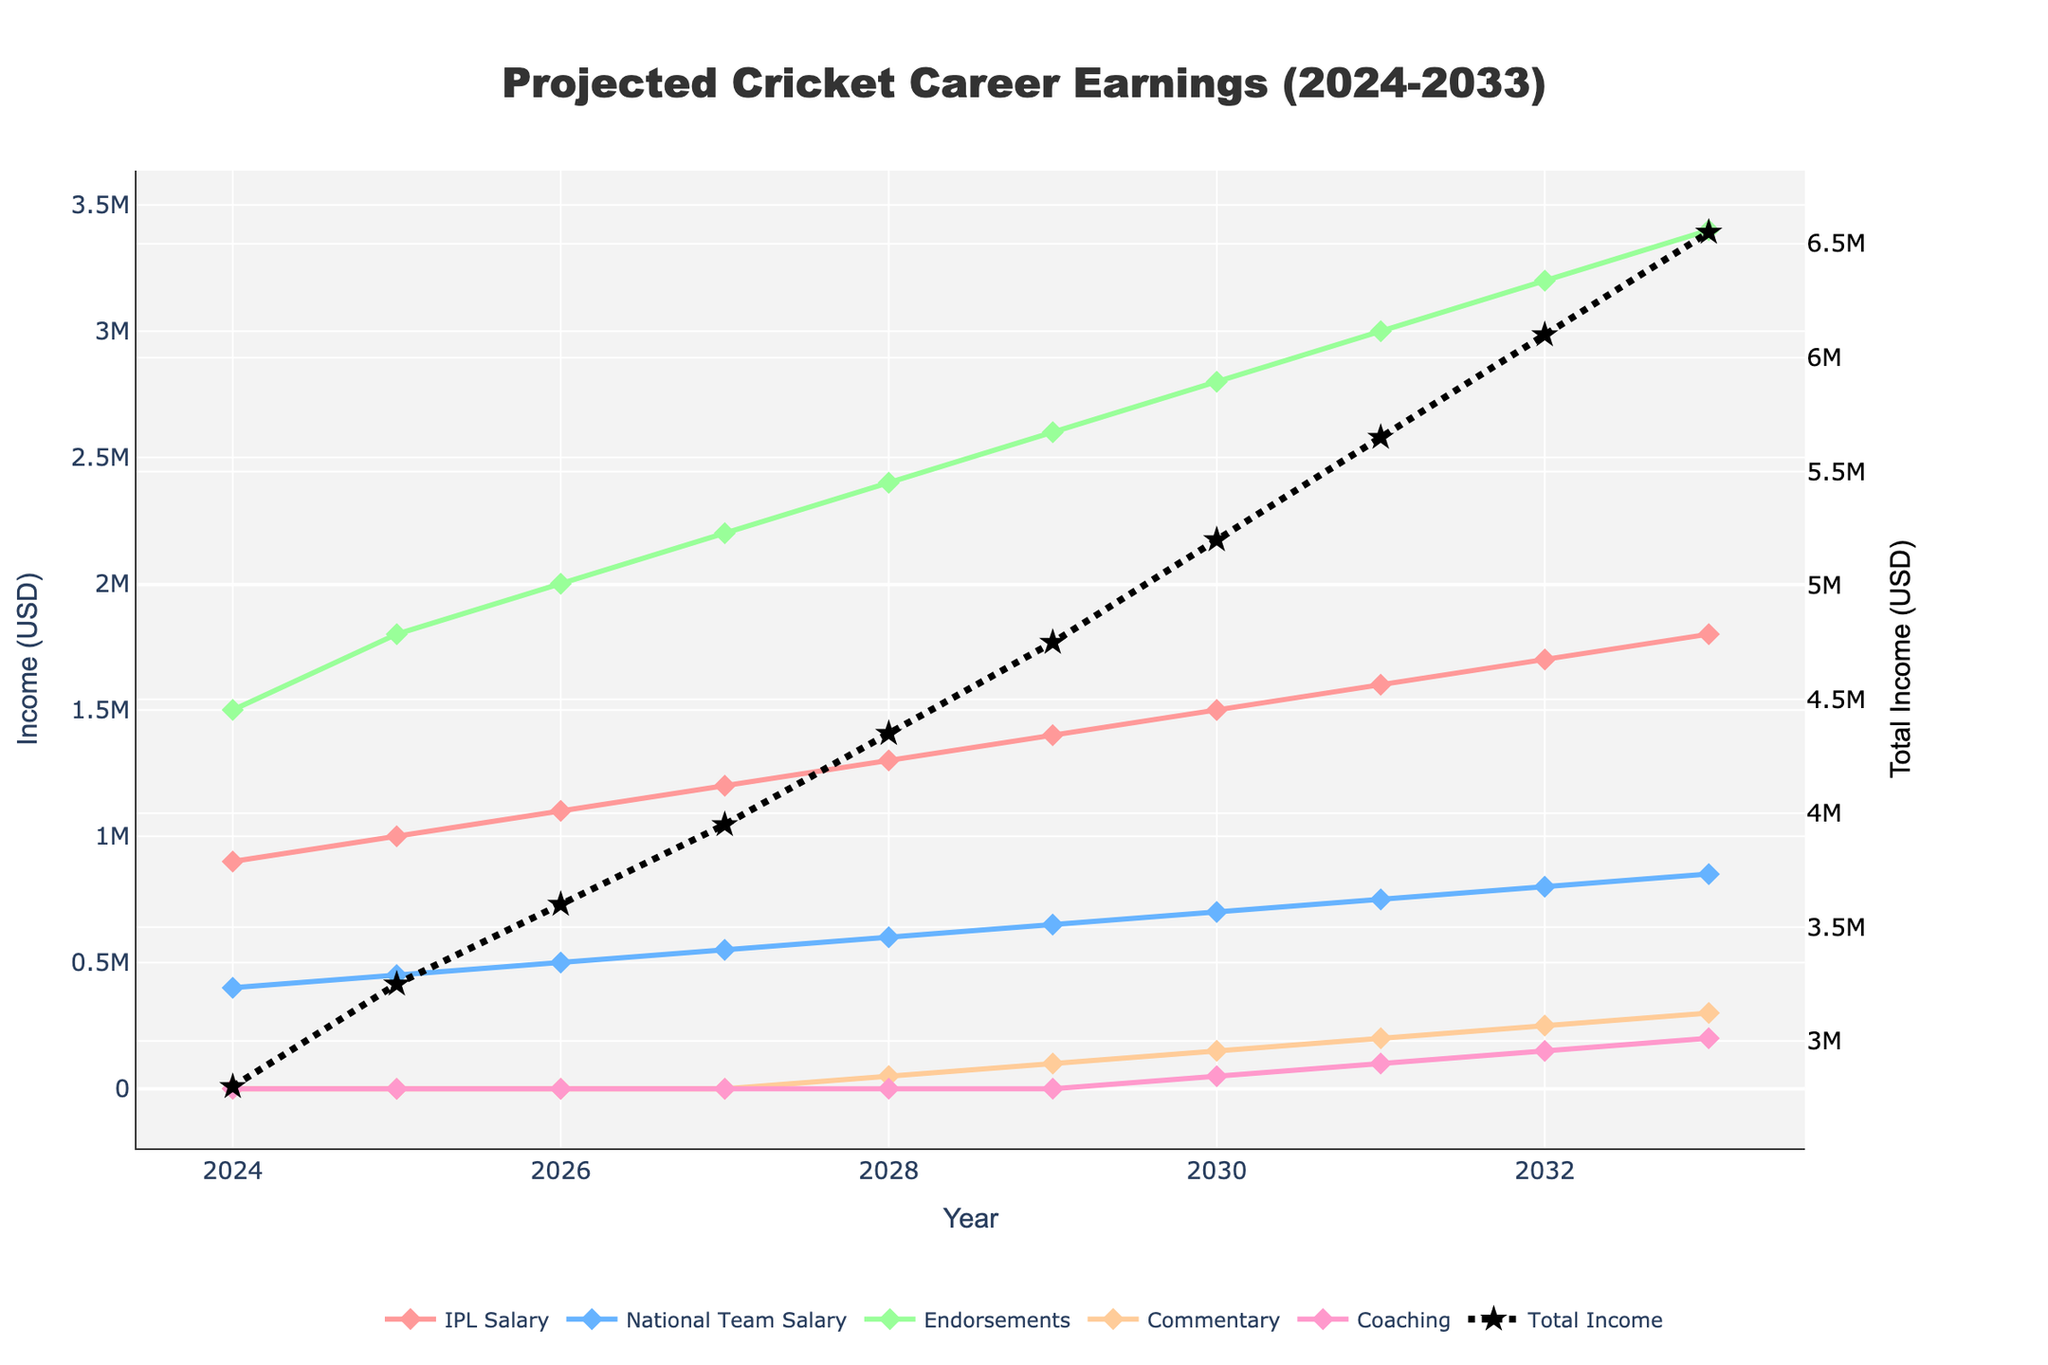What is the title of the chart? The title is usually given at the top of the chart and provides a summary of what the chart is about. In this case, it is related to projected cricket career earnings.
Answer: Projected Cricket Career Earnings (2024-2033) How many income sources are shown in the chart? Count the number of unique lines or data series in the chart, excluding the total income line. These represent different income sources.
Answer: Five Which year has the highest projected total income? Look for the year where the 'Total Income' trace (black line with star markers) reaches its maximum value.
Answer: 2033 What are the projected IPL Salary and National Team Salary in the year 2028? Locate the points corresponding to the year 2028 on the lines for 'IPL Salary' and 'National Team Salary'. The y-axis values at these points give the respective incomes.
Answer: 1300000 USD (IPL Salary), 600000 USD (National Team Salary) In which year do Commentary earnings start to appear? Check the Commentary trace on the plot and identify the first year where the earnings are greater than zero.
Answer: 2028 By how much does the total income increase from 2024 to 2030? Calculate the difference between total income values for the years 2024 and 2030 as represented by the 'Total Income' line.
Answer: 5,300,000 USD (6,900,000 USD - 1,600,000 USD) What is the combined income from Coaching and Commentary in 2033? Sum the y-axis values for Coaching and Commentary in the year 2033.
Answer: 500,000 USD (200,000 USD + 300,000 USD) Which income source shows a steady increase from 2024 to 2033? Observe the trends of each income source over the years and determine which one exhibits a consistent upward trajectory.
Answer: Endorsements Is the increase in IPL Salary greater than or less than the increase in National Team Salary from 2024 to 2033? Calculate the difference between the start and end values of IPL Salary and compare it with the difference for National Team Salary over the same period.
Answer: Greater What proportion of the total income in 2031 is contributed by Endorsements? Divide the Endorsements value by the Total Income value for 2031 and express it as a percentage.
Answer: Approximately 52.63% (3000000 USD / 5700000 USD * 100) 